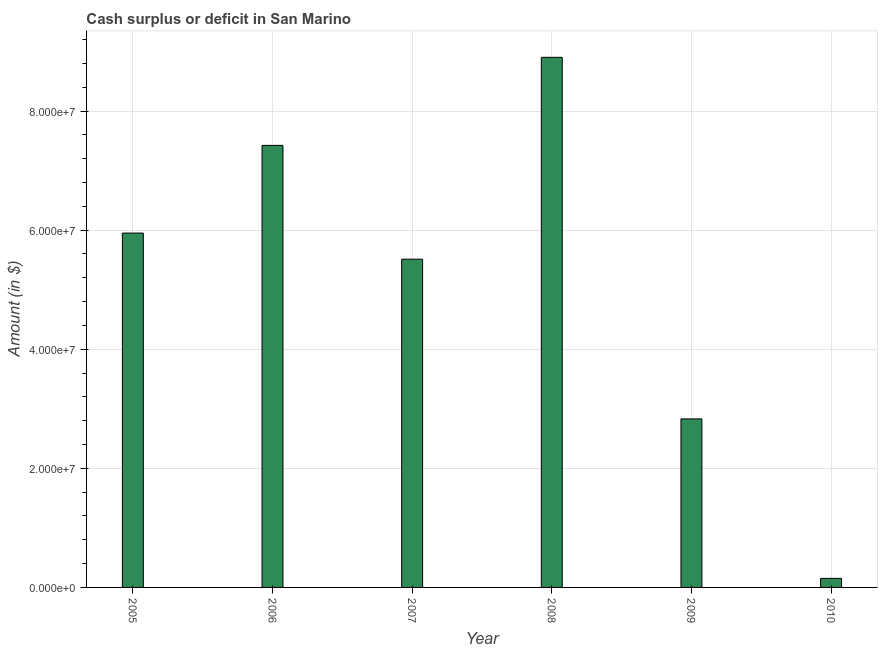Does the graph contain any zero values?
Your answer should be compact. No. What is the title of the graph?
Ensure brevity in your answer.  Cash surplus or deficit in San Marino. What is the label or title of the Y-axis?
Give a very brief answer. Amount (in $). What is the cash surplus or deficit in 2008?
Offer a terse response. 8.90e+07. Across all years, what is the maximum cash surplus or deficit?
Your response must be concise. 8.90e+07. Across all years, what is the minimum cash surplus or deficit?
Your response must be concise. 1.52e+06. In which year was the cash surplus or deficit maximum?
Provide a short and direct response. 2008. What is the sum of the cash surplus or deficit?
Keep it short and to the point. 3.08e+08. What is the difference between the cash surplus or deficit in 2006 and 2009?
Your answer should be very brief. 4.59e+07. What is the average cash surplus or deficit per year?
Keep it short and to the point. 5.13e+07. What is the median cash surplus or deficit?
Give a very brief answer. 5.73e+07. In how many years, is the cash surplus or deficit greater than 52000000 $?
Offer a terse response. 4. What is the ratio of the cash surplus or deficit in 2008 to that in 2010?
Your response must be concise. 58.48. Is the difference between the cash surplus or deficit in 2007 and 2009 greater than the difference between any two years?
Keep it short and to the point. No. What is the difference between the highest and the second highest cash surplus or deficit?
Offer a terse response. 1.48e+07. What is the difference between the highest and the lowest cash surplus or deficit?
Your answer should be compact. 8.75e+07. Are all the bars in the graph horizontal?
Provide a succinct answer. No. How many years are there in the graph?
Your answer should be compact. 6. What is the difference between two consecutive major ticks on the Y-axis?
Offer a terse response. 2.00e+07. Are the values on the major ticks of Y-axis written in scientific E-notation?
Ensure brevity in your answer.  Yes. What is the Amount (in $) of 2005?
Offer a very short reply. 5.95e+07. What is the Amount (in $) in 2006?
Offer a terse response. 7.42e+07. What is the Amount (in $) in 2007?
Your answer should be very brief. 5.51e+07. What is the Amount (in $) of 2008?
Your response must be concise. 8.90e+07. What is the Amount (in $) in 2009?
Your response must be concise. 2.83e+07. What is the Amount (in $) in 2010?
Keep it short and to the point. 1.52e+06. What is the difference between the Amount (in $) in 2005 and 2006?
Your answer should be compact. -1.47e+07. What is the difference between the Amount (in $) in 2005 and 2007?
Ensure brevity in your answer.  4.39e+06. What is the difference between the Amount (in $) in 2005 and 2008?
Make the answer very short. -2.95e+07. What is the difference between the Amount (in $) in 2005 and 2009?
Provide a succinct answer. 3.12e+07. What is the difference between the Amount (in $) in 2005 and 2010?
Keep it short and to the point. 5.80e+07. What is the difference between the Amount (in $) in 2006 and 2007?
Offer a terse response. 1.91e+07. What is the difference between the Amount (in $) in 2006 and 2008?
Keep it short and to the point. -1.48e+07. What is the difference between the Amount (in $) in 2006 and 2009?
Make the answer very short. 4.59e+07. What is the difference between the Amount (in $) in 2006 and 2010?
Make the answer very short. 7.27e+07. What is the difference between the Amount (in $) in 2007 and 2008?
Your answer should be very brief. -3.39e+07. What is the difference between the Amount (in $) in 2007 and 2009?
Keep it short and to the point. 2.68e+07. What is the difference between the Amount (in $) in 2007 and 2010?
Offer a terse response. 5.36e+07. What is the difference between the Amount (in $) in 2008 and 2009?
Your response must be concise. 6.07e+07. What is the difference between the Amount (in $) in 2008 and 2010?
Make the answer very short. 8.75e+07. What is the difference between the Amount (in $) in 2009 and 2010?
Your response must be concise. 2.68e+07. What is the ratio of the Amount (in $) in 2005 to that in 2006?
Offer a very short reply. 0.8. What is the ratio of the Amount (in $) in 2005 to that in 2007?
Your answer should be compact. 1.08. What is the ratio of the Amount (in $) in 2005 to that in 2008?
Give a very brief answer. 0.67. What is the ratio of the Amount (in $) in 2005 to that in 2009?
Keep it short and to the point. 2.1. What is the ratio of the Amount (in $) in 2005 to that in 2010?
Provide a succinct answer. 39.09. What is the ratio of the Amount (in $) in 2006 to that in 2007?
Your answer should be compact. 1.35. What is the ratio of the Amount (in $) in 2006 to that in 2008?
Make the answer very short. 0.83. What is the ratio of the Amount (in $) in 2006 to that in 2009?
Your answer should be compact. 2.62. What is the ratio of the Amount (in $) in 2006 to that in 2010?
Provide a succinct answer. 48.77. What is the ratio of the Amount (in $) in 2007 to that in 2008?
Your response must be concise. 0.62. What is the ratio of the Amount (in $) in 2007 to that in 2009?
Your response must be concise. 1.95. What is the ratio of the Amount (in $) in 2007 to that in 2010?
Your answer should be very brief. 36.21. What is the ratio of the Amount (in $) in 2008 to that in 2009?
Make the answer very short. 3.15. What is the ratio of the Amount (in $) in 2008 to that in 2010?
Keep it short and to the point. 58.48. What is the ratio of the Amount (in $) in 2009 to that in 2010?
Ensure brevity in your answer.  18.59. 